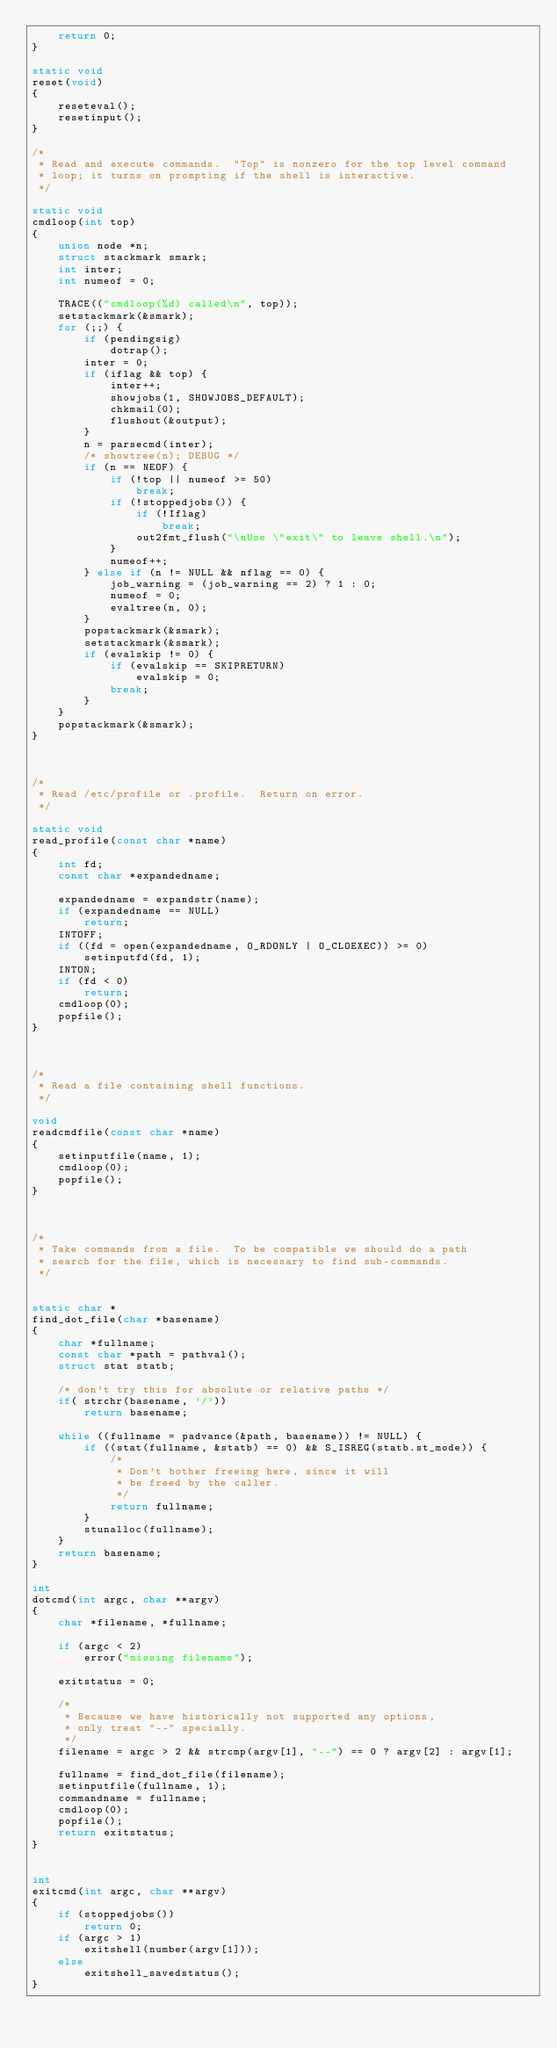Convert code to text. <code><loc_0><loc_0><loc_500><loc_500><_C_>	return 0;
}

static void
reset(void)
{
	reseteval();
	resetinput();
}

/*
 * Read and execute commands.  "Top" is nonzero for the top level command
 * loop; it turns on prompting if the shell is interactive.
 */

static void
cmdloop(int top)
{
	union node *n;
	struct stackmark smark;
	int inter;
	int numeof = 0;

	TRACE(("cmdloop(%d) called\n", top));
	setstackmark(&smark);
	for (;;) {
		if (pendingsig)
			dotrap();
		inter = 0;
		if (iflag && top) {
			inter++;
			showjobs(1, SHOWJOBS_DEFAULT);
			chkmail(0);
			flushout(&output);
		}
		n = parsecmd(inter);
		/* showtree(n); DEBUG */
		if (n == NEOF) {
			if (!top || numeof >= 50)
				break;
			if (!stoppedjobs()) {
				if (!Iflag)
					break;
				out2fmt_flush("\nUse \"exit\" to leave shell.\n");
			}
			numeof++;
		} else if (n != NULL && nflag == 0) {
			job_warning = (job_warning == 2) ? 1 : 0;
			numeof = 0;
			evaltree(n, 0);
		}
		popstackmark(&smark);
		setstackmark(&smark);
		if (evalskip != 0) {
			if (evalskip == SKIPRETURN)
				evalskip = 0;
			break;
		}
	}
	popstackmark(&smark);
}



/*
 * Read /etc/profile or .profile.  Return on error.
 */

static void
read_profile(const char *name)
{
	int fd;
	const char *expandedname;

	expandedname = expandstr(name);
	if (expandedname == NULL)
		return;
	INTOFF;
	if ((fd = open(expandedname, O_RDONLY | O_CLOEXEC)) >= 0)
		setinputfd(fd, 1);
	INTON;
	if (fd < 0)
		return;
	cmdloop(0);
	popfile();
}



/*
 * Read a file containing shell functions.
 */

void
readcmdfile(const char *name)
{
	setinputfile(name, 1);
	cmdloop(0);
	popfile();
}



/*
 * Take commands from a file.  To be compatible we should do a path
 * search for the file, which is necessary to find sub-commands.
 */


static char *
find_dot_file(char *basename)
{
	char *fullname;
	const char *path = pathval();
	struct stat statb;

	/* don't try this for absolute or relative paths */
	if( strchr(basename, '/'))
		return basename;

	while ((fullname = padvance(&path, basename)) != NULL) {
		if ((stat(fullname, &statb) == 0) && S_ISREG(statb.st_mode)) {
			/*
			 * Don't bother freeing here, since it will
			 * be freed by the caller.
			 */
			return fullname;
		}
		stunalloc(fullname);
	}
	return basename;
}

int
dotcmd(int argc, char **argv)
{
	char *filename, *fullname;

	if (argc < 2)
		error("missing filename");

	exitstatus = 0;

	/*
	 * Because we have historically not supported any options,
	 * only treat "--" specially.
	 */
	filename = argc > 2 && strcmp(argv[1], "--") == 0 ? argv[2] : argv[1];

	fullname = find_dot_file(filename);
	setinputfile(fullname, 1);
	commandname = fullname;
	cmdloop(0);
	popfile();
	return exitstatus;
}


int
exitcmd(int argc, char **argv)
{
	if (stoppedjobs())
		return 0;
	if (argc > 1)
		exitshell(number(argv[1]));
	else
		exitshell_savedstatus();
}
</code> 